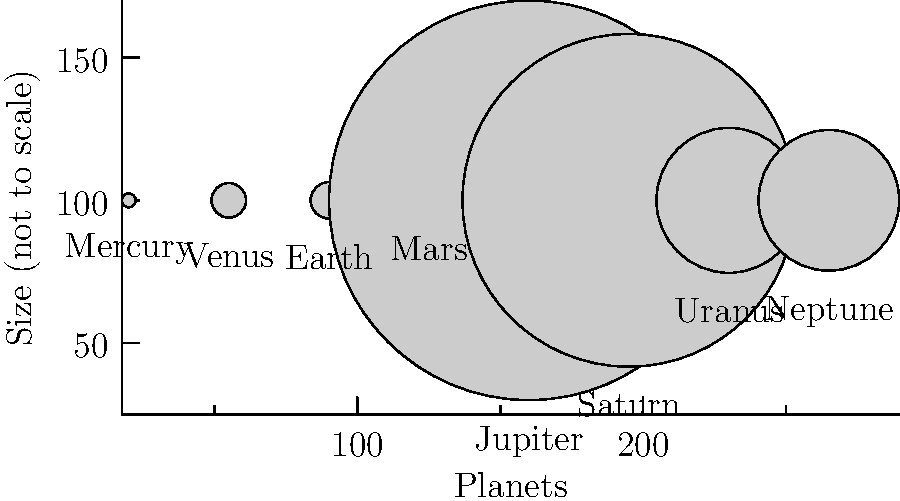As a corporate event manager planning a space-themed gala, you're creating an educational display about our solar system. Which planet would be the largest sphere in your scale model, and approximately how many times larger is its diameter compared to Earth's? To answer this question, let's follow these steps:

1. Identify the largest planet:
   Looking at the diagram, we can see that Jupiter is the largest planet.

2. Compare Jupiter's diameter to Earth's:
   - Jupiter's diameter: 139,820 km
   - Earth's diameter: 12,742 km

3. Calculate the ratio:
   $\frac{\text{Jupiter's diameter}}{\text{Earth's diameter}} = \frac{139,820}{12,742} \approx 10.97$

4. Round to the nearest whole number:
   10.97 rounds to 11

Therefore, Jupiter would be the largest sphere in the scale model, and its diameter would be approximately 11 times larger than Earth's.
Answer: Jupiter, 11 times larger 